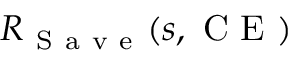Convert formula to latex. <formula><loc_0><loc_0><loc_500><loc_500>R _ { S a v e } ( s , C E )</formula> 